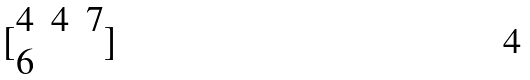Convert formula to latex. <formula><loc_0><loc_0><loc_500><loc_500>[ \begin{matrix} 4 & 4 & 7 \\ 6 \end{matrix} ]</formula> 